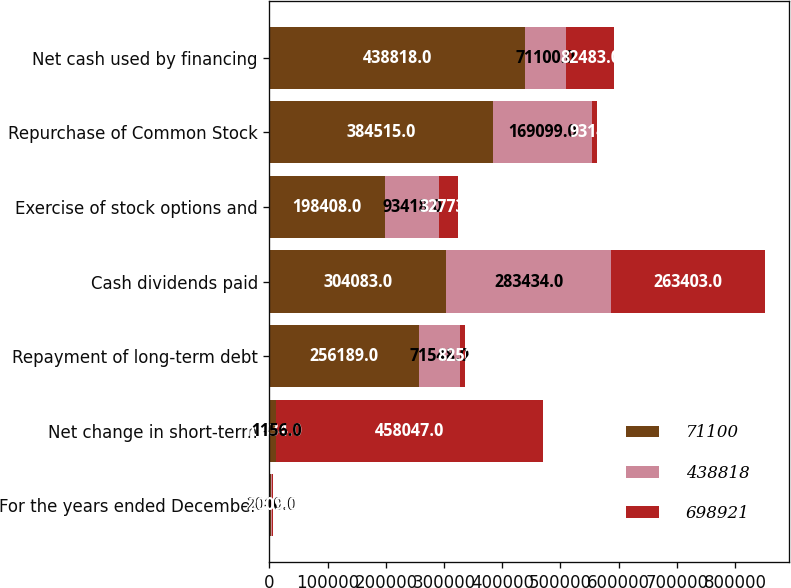Convert chart. <chart><loc_0><loc_0><loc_500><loc_500><stacked_bar_chart><ecel><fcel>For the years ended December<fcel>Net change in short-term<fcel>Repayment of long-term debt<fcel>Cash dividends paid<fcel>Exercise of stock options and<fcel>Repurchase of Common Stock<fcel>Net cash used by financing<nl><fcel>71100<fcel>2011<fcel>10834<fcel>256189<fcel>304083<fcel>198408<fcel>384515<fcel>438818<nl><fcel>438818<fcel>2010<fcel>1156<fcel>71548<fcel>283434<fcel>93418<fcel>169099<fcel>71100<nl><fcel>698921<fcel>2009<fcel>458047<fcel>8252<fcel>263403<fcel>32773<fcel>9314<fcel>82483<nl></chart> 